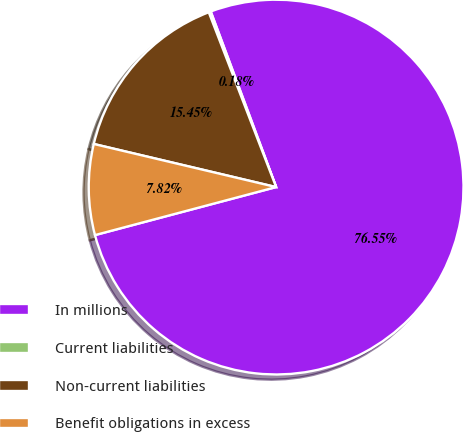<chart> <loc_0><loc_0><loc_500><loc_500><pie_chart><fcel>In millions<fcel>Current liabilities<fcel>Non-current liabilities<fcel>Benefit obligations in excess<nl><fcel>76.55%<fcel>0.18%<fcel>15.45%<fcel>7.82%<nl></chart> 